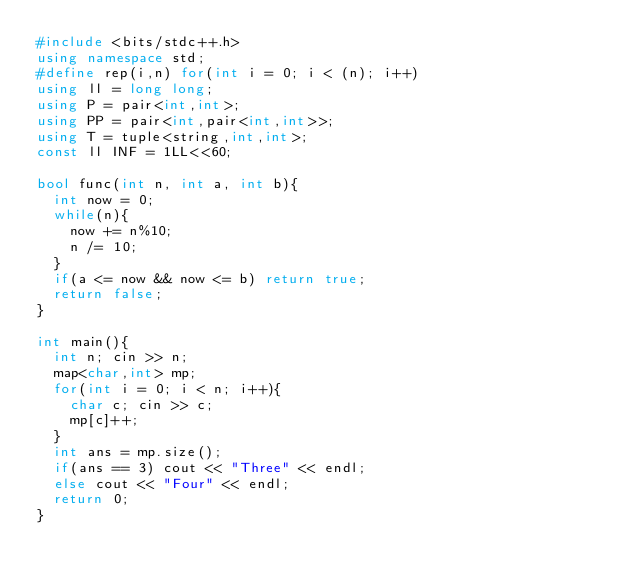Convert code to text. <code><loc_0><loc_0><loc_500><loc_500><_C++_>#include <bits/stdc++.h>
using namespace std;
#define rep(i,n) for(int i = 0; i < (n); i++)
using ll = long long;
using P = pair<int,int>;
using PP = pair<int,pair<int,int>>;
using T = tuple<string,int,int>;
const ll INF = 1LL<<60;

bool func(int n, int a, int b){
  int now = 0;
  while(n){
    now += n%10;
    n /= 10;
  }
  if(a <= now && now <= b) return true;
  return false;
}

int main(){
  int n; cin >> n;
  map<char,int> mp;
  for(int i = 0; i < n; i++){
    char c; cin >> c;
    mp[c]++;
  }
  int ans = mp.size();
  if(ans == 3) cout << "Three" << endl;
  else cout << "Four" << endl;
  return 0;
}
</code> 